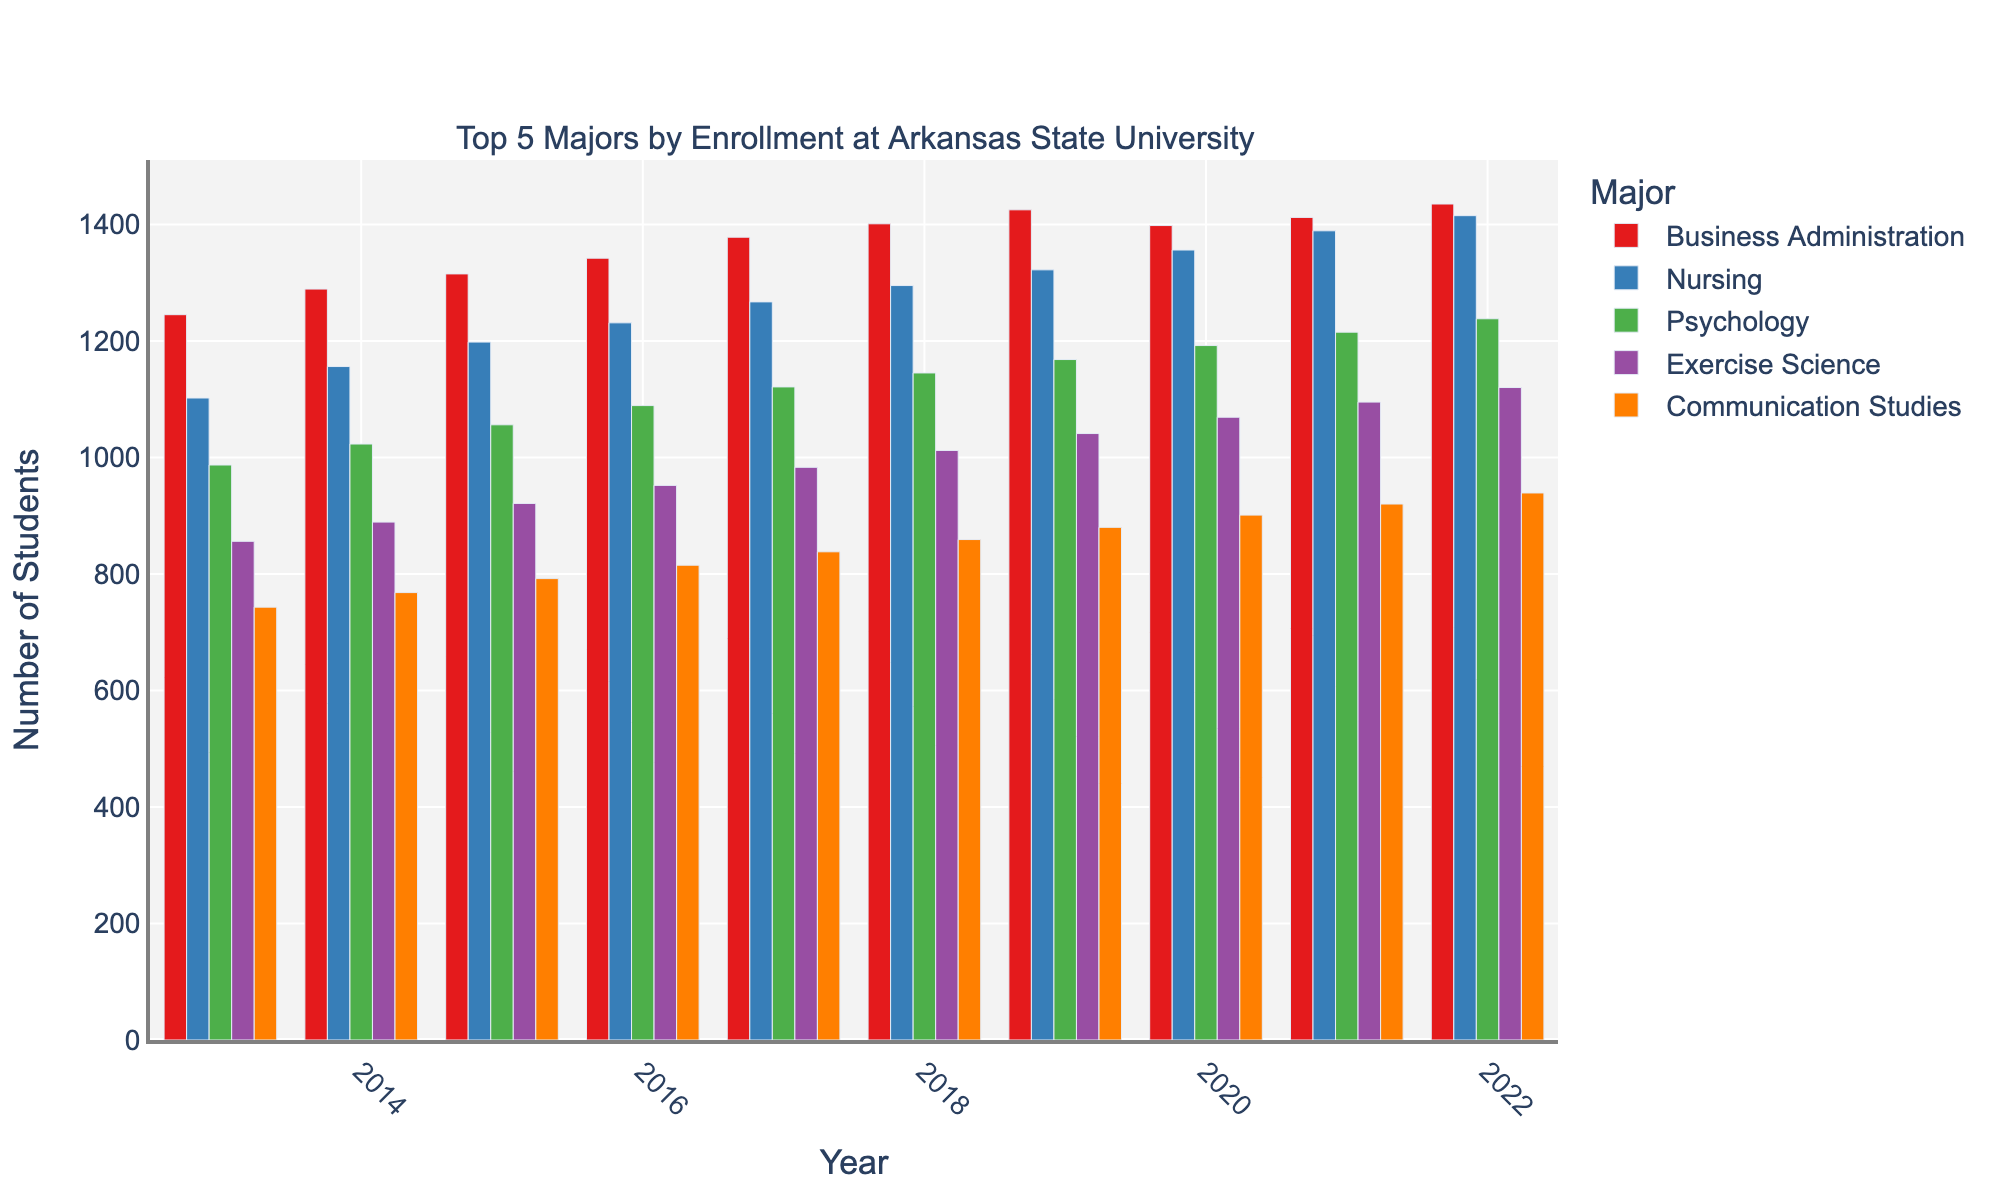what are the two majors with the highest and lowest enrollments in 2022? In 2022, the major with the highest enrollment is Business Administration, while the one with the lowest is Communication Studies. This can be determined by comparing the heights of the bars for each major in the year 2022.
Answer: Business Administration, Communication Studies Which major showed the steadiest year-over-year growth in enrollment? To find which major showed the steadiest growth, look for the bars' heights increasing consistently over the years. Nursing has the most consistent increment without significant fluctuation from year to year.
Answer: Nursing What's the difference in enrollment between Business Administration and Nursing in 2022? In 2022, Business Administration had 1435 students enrolled, while Nursing had 1415. The difference is calculated by subtracting 1415 from 1435.
Answer: 20 Which major experienced the largest increase in student enrollment from 2013 to 2022? The major with the largest increase can be found by calculating the difference between the 2013 and 2022 enrollments for each major. Business Administration had an increase from 1245 in 2013 to 1435 in 2022, which is an increase of 190.
Answer: Business Administration In what year did Exercise Science surpass the 1000 student enrollment mark? Observing the bar heights for Exercise Science, it reaches just above 1000 between the years shown. In 2018, the enrollment is 1012, surpassing the 1000 mark.
Answer: 2018 Which major had the smallest growth in enrollment over the decade? Comparing the differences from 2013 to 2022 for each major, Communication Studies had the smallest increase, growing from 743 to 939, which is a difference of 196.
Answer: Communication Studies Was there any year where enrollments dropped for any major? By examining the bar heights over the years, no major showed a decline. Every major's bars either stayed steady or grew year-over-year.
Answer: No Calculate the average enrollment for Psychology from 2013 to 2022. Adding all the enrollments for Psychology from each year (987, 1023, 1056, 1089, 1121, 1145, 1168, 1192, 1215, 1238) and then dividing by the number of years (10) gives the average. The sum is 11234, so the average is 1123.4.
Answer: 1123.4 Which color bar represents Nursing, and what is its trend over the decade? The blue bar represents Nursing. Over the decade, it shows a consistently upward trend, increasing from 1102 in 2013 to 1415 in 2022.
Answer: Blue, increasing 